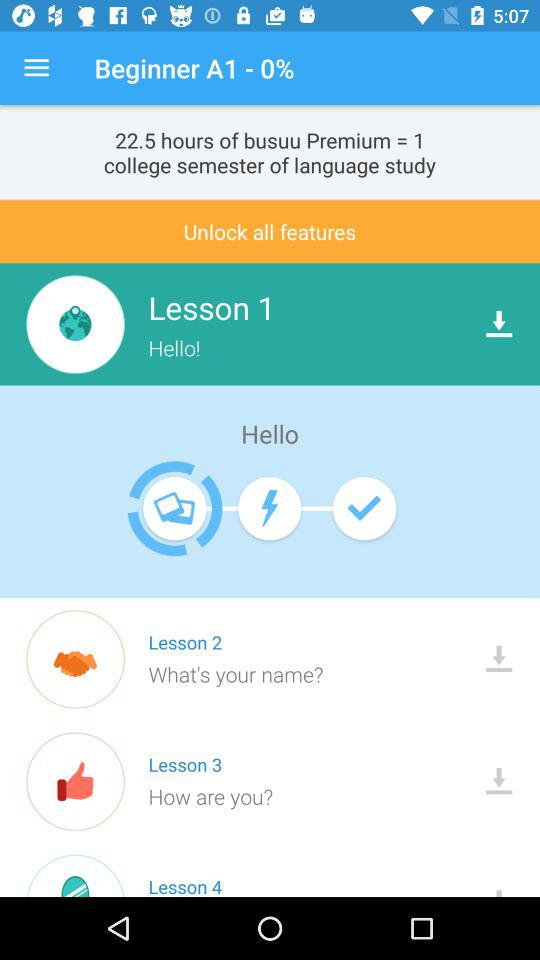How many lessons are there in total?
Answer the question using a single word or phrase. 4 